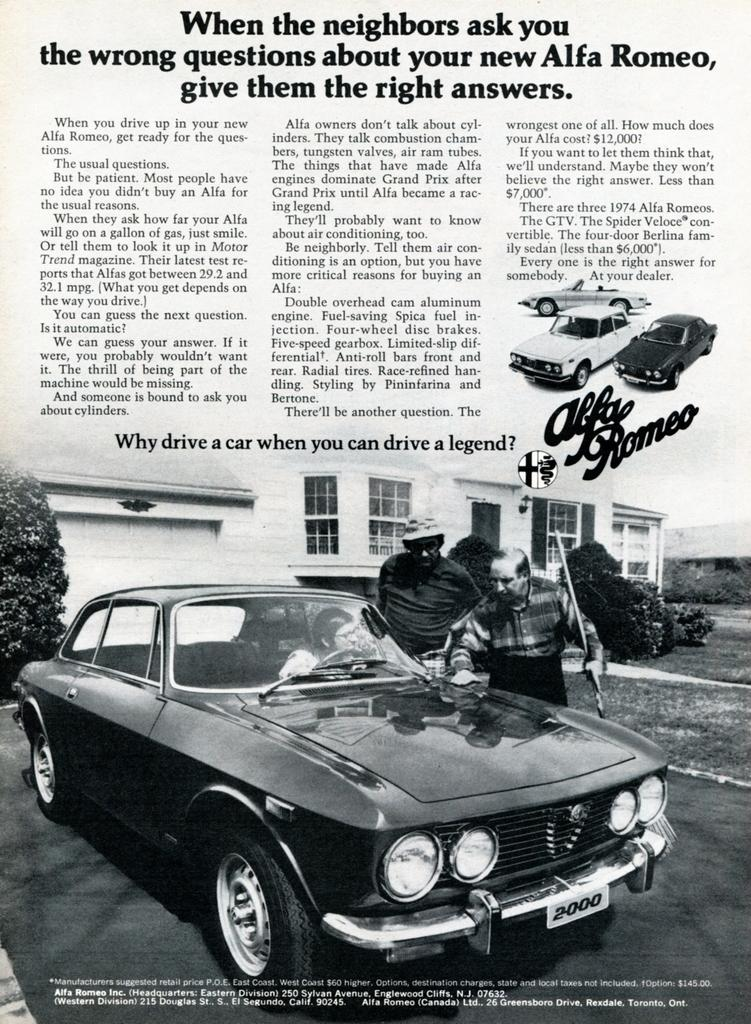What type of print media is shown in the image? The image is of a newspaper. What can be seen in the foreground of the image? There is a car in the foreground of the image. What is the primary content of the newspaper? There is text visible in the image, which suggests that the newspaper contains articles and information. What type of rice is being advertised on the front page of the newspaper? There is no rice being advertised on the front page of the newspaper, as the image only shows a car in the foreground and text on the newspaper. 